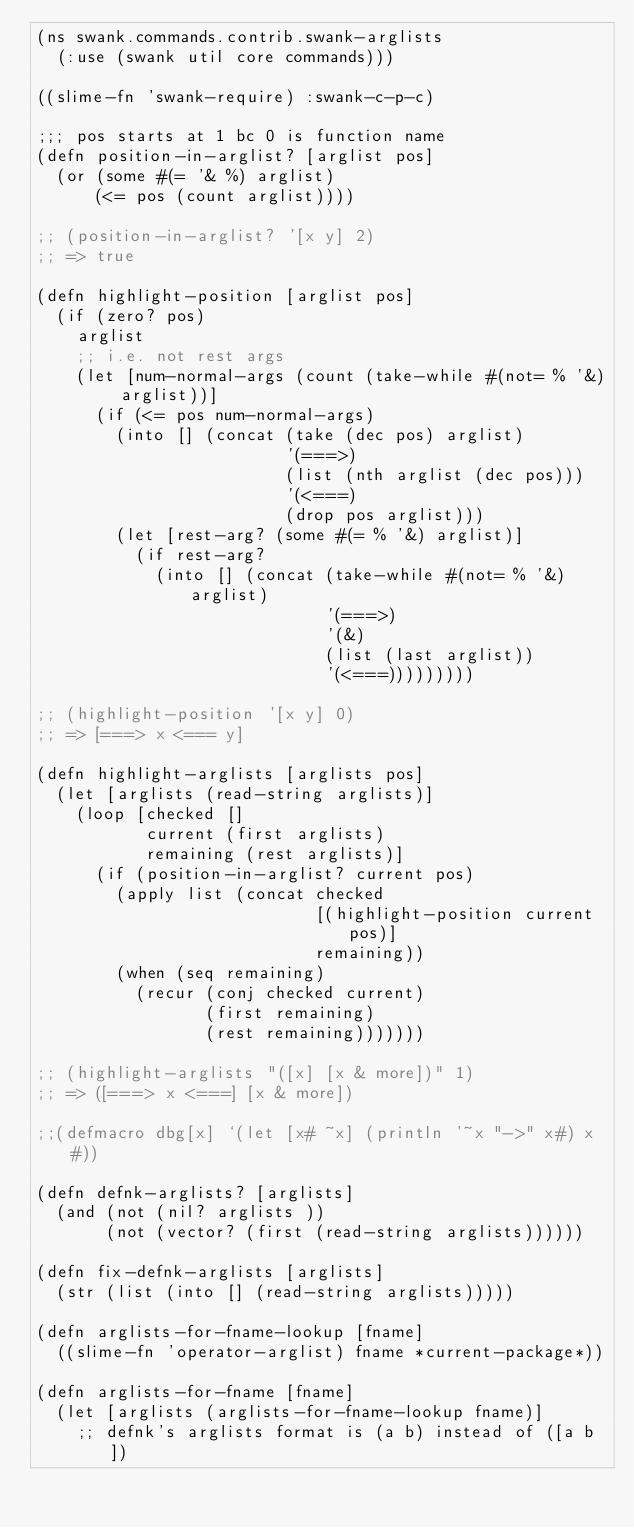Convert code to text. <code><loc_0><loc_0><loc_500><loc_500><_Clojure_>(ns swank.commands.contrib.swank-arglists
  (:use (swank util core commands)))

((slime-fn 'swank-require) :swank-c-p-c)

;;; pos starts at 1 bc 0 is function name
(defn position-in-arglist? [arglist pos]
  (or (some #(= '& %) arglist)
      (<= pos (count arglist))))

;; (position-in-arglist? '[x y] 2)
;; => true

(defn highlight-position [arglist pos]
  (if (zero? pos)
    arglist
    ;; i.e. not rest args
    (let [num-normal-args (count (take-while #(not= % '&) arglist))]
      (if (<= pos num-normal-args)
        (into [] (concat (take (dec pos) arglist)
                         '(===>)
                         (list (nth arglist (dec pos)))
                         '(<===)
                         (drop pos arglist)))
        (let [rest-arg? (some #(= % '&) arglist)]
          (if rest-arg?
            (into [] (concat (take-while #(not= % '&) arglist)
                             '(===>)
                             '(&)
                             (list (last arglist))
                             '(<===)))))))))

;; (highlight-position '[x y] 0)
;; => [===> x <=== y]

(defn highlight-arglists [arglists pos]
  (let [arglists (read-string arglists)]
    (loop [checked []
           current (first arglists)
           remaining (rest arglists)]
      (if (position-in-arglist? current pos)
        (apply list (concat checked
                            [(highlight-position current pos)]
                            remaining))
        (when (seq remaining)
          (recur (conj checked current)
                 (first remaining)
                 (rest remaining)))))))

;; (highlight-arglists "([x] [x & more])" 1)
;; => ([===> x <===] [x & more])

;;(defmacro dbg[x] `(let [x# ~x] (println '~x "->" x#) x#))

(defn defnk-arglists? [arglists]
  (and (not (nil? arglists ))
       (not (vector? (first (read-string arglists))))))

(defn fix-defnk-arglists [arglists]
  (str (list (into [] (read-string arglists)))))

(defn arglists-for-fname-lookup [fname]
  ((slime-fn 'operator-arglist) fname *current-package*))

(defn arglists-for-fname [fname]
  (let [arglists (arglists-for-fname-lookup fname)]
    ;; defnk's arglists format is (a b) instead of ([a b])</code> 